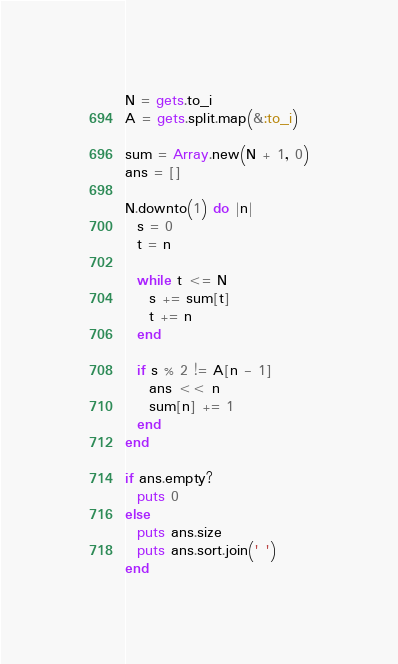Convert code to text. <code><loc_0><loc_0><loc_500><loc_500><_Ruby_>N = gets.to_i
A = gets.split.map(&:to_i)

sum = Array.new(N + 1, 0)
ans = []

N.downto(1) do |n|
  s = 0
  t = n

  while t <= N
    s += sum[t]
    t += n
  end

  if s % 2 != A[n - 1]
    ans << n
    sum[n] += 1
  end
end

if ans.empty?
  puts 0
else
  puts ans.size
  puts ans.sort.join(' ')
end
</code> 